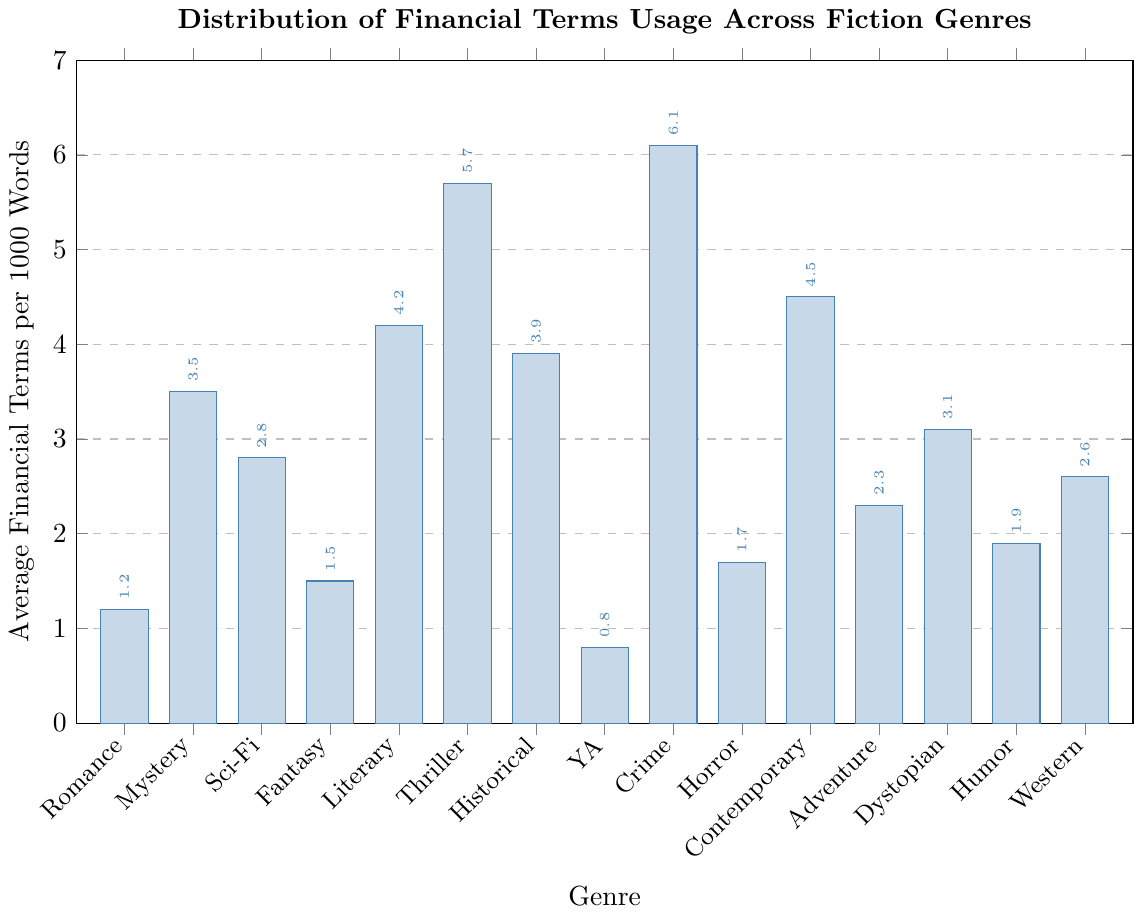Which genre has the highest average usage of financial terms? By examining the height of the bars, the genre with the highest bar indicates the highest usage. Crime has the tallest bar with a value of 6.1.
Answer: Crime Which genres have a lower average usage of financial terms than Science Fiction? Science Fiction has an average of 2.8. From the figure, genres with lower values are Romance (1.2), Fantasy (1.5), Young Adult (0.8), Horror (1.7), Humor (1.9), and Western (2.6).
Answer: Romance, Fantasy, Young Adult, Horror, Humor, Western What is the difference in average usage of financial terms between Thriller and Contemporary Fiction? Thriller has an average usage of 5.7, and Contemporary Fiction has 4.5. The difference is calculated as 5.7 - 4.5 = 1.2.
Answer: 1.2 Which three genres have the closest average usage of financial terms? To find the three closest values, compare the bars visually and find the ones with minimal differences. Fantasy (1.5), Horror (1.7), and Humor (1.9) are the three closest values.
Answer: Fantasy, Horror, Humor How many genres have an average usage of financial terms greater than 4? Count the bars with values above 4: Literary Fiction (4.2), Thriller (5.7), Crime (6.1), and Contemporary Fiction (4.5). There are 4 genres.
Answer: 4 Is the average usage of financial terms in Dystopian fiction higher or lower than in Historical Fiction? Dystopian fiction has an average usage of 3.1, and Historical Fiction has 3.9. Comparing the two, Dystopian is lower.
Answer: Lower What is the summed average usage of financial terms for the genres Romance, Horror, and Adventure? Add the averages for Romance (1.2), Horror (1.7), and Adventure (2.3). The sum is 1.2 + 1.7 + 2.3 = 5.2.
Answer: 5.2 Which genre has the least average usage of financial terms? The genre with the shortest bar indicates the least usage. Young Adult has the shortest bar with a value of 0.8.
Answer: Young Adult 